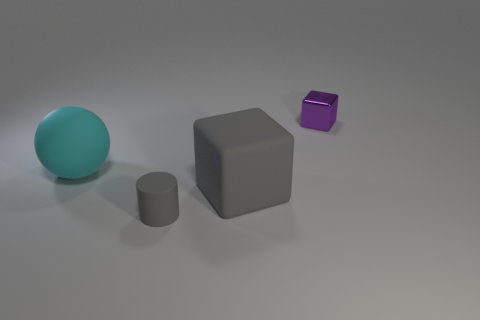Add 4 big gray objects. How many objects exist? 8 Subtract all balls. How many objects are left? 3 Subtract all objects. Subtract all small brown blocks. How many objects are left? 0 Add 2 metallic cubes. How many metallic cubes are left? 3 Add 1 tiny gray cylinders. How many tiny gray cylinders exist? 2 Subtract 0 brown blocks. How many objects are left? 4 